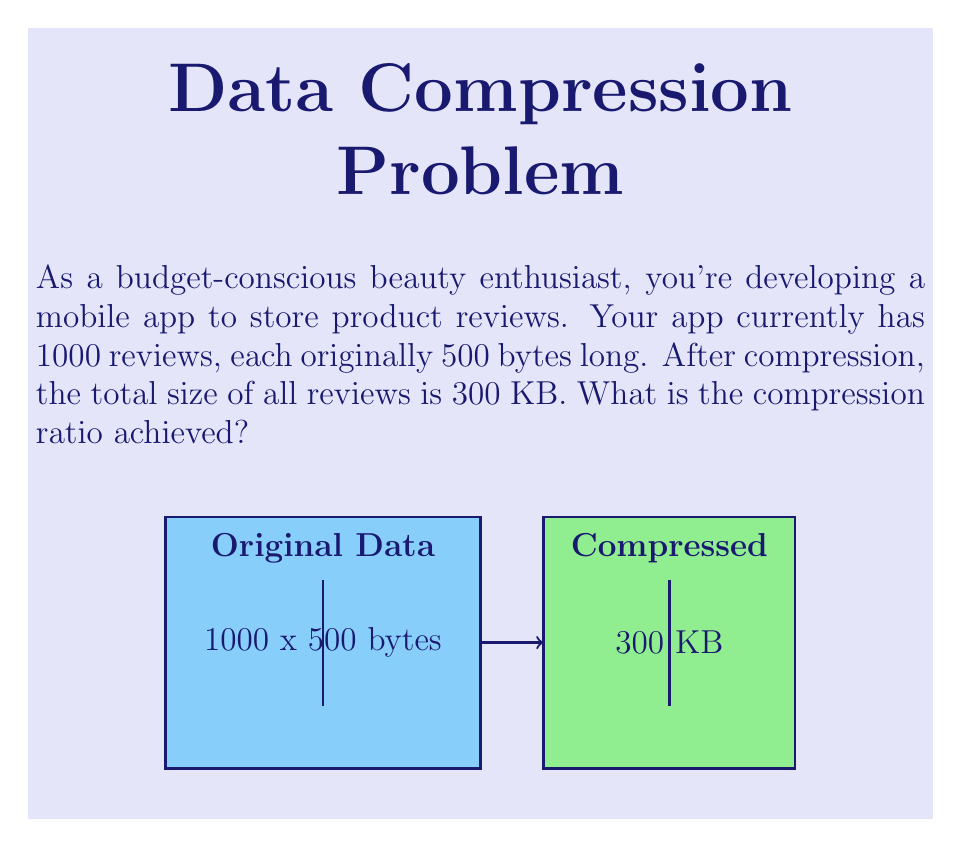What is the answer to this math problem? Let's approach this step-by-step:

1. Calculate the original size of the data:
   - Number of reviews: 1000
   - Size of each review: 500 bytes
   - Total original size: $1000 \times 500 = 500,000$ bytes

2. Convert the compressed size to bytes:
   - Compressed size: 300 KB
   - 1 KB = 1024 bytes
   - Compressed size in bytes: $300 \times 1024 = 307,200$ bytes

3. Calculate the compression ratio using the formula:
   $$ \text{Compression Ratio} = \frac{\text{Original Size}}{\text{Compressed Size}} $$

4. Plug in the values:
   $$ \text{Compression Ratio} = \frac{500,000 \text{ bytes}}{307,200 \text{ bytes}} $$

5. Perform the division:
   $$ \text{Compression Ratio} \approx 1.6276 $$

6. Round to two decimal places:
   $$ \text{Compression Ratio} \approx 1.63 $$

This means that the original data is 1.63 times larger than the compressed data, indicating a significant space saving for your budget-friendly app.
Answer: 1.63 